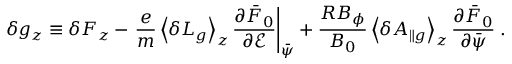<formula> <loc_0><loc_0><loc_500><loc_500>\delta g _ { z } \equiv \delta F _ { z } - \frac { e } { m } \left \langle \delta L _ { g } \right \rangle _ { z } \frac { \partial \bar { F } _ { 0 } } { \partial \mathcal { E } } \right | _ { \bar { \psi } } + \frac { R B _ { \phi } } { B _ { 0 } } \left \langle \delta A _ { \| g } \right \rangle _ { z } \frac { \partial \bar { F } _ { 0 } } { \partial \bar { \psi } } \, .</formula> 